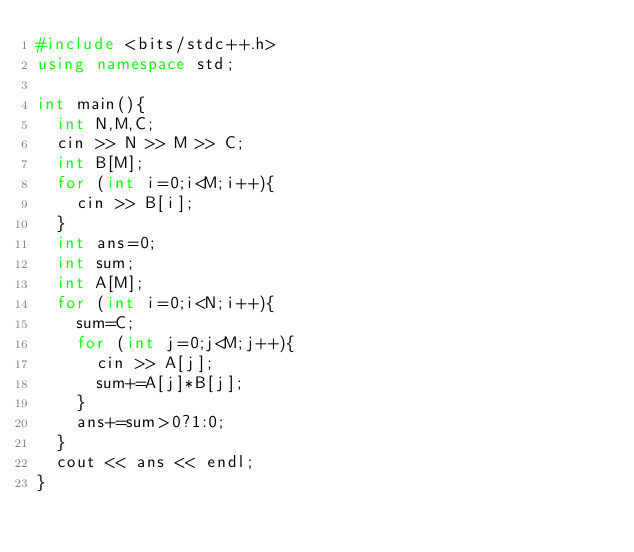Convert code to text. <code><loc_0><loc_0><loc_500><loc_500><_C++_>#include <bits/stdc++.h>
using namespace std;

int main(){
  int N,M,C;
  cin >> N >> M >> C;
  int B[M];
  for (int i=0;i<M;i++){
    cin >> B[i];
  }
  int ans=0;
  int sum;
  int A[M];
  for (int i=0;i<N;i++){
    sum=C;
    for (int j=0;j<M;j++){
      cin >> A[j];
      sum+=A[j]*B[j];
    }
    ans+=sum>0?1:0;
  }
  cout << ans << endl;
}
</code> 